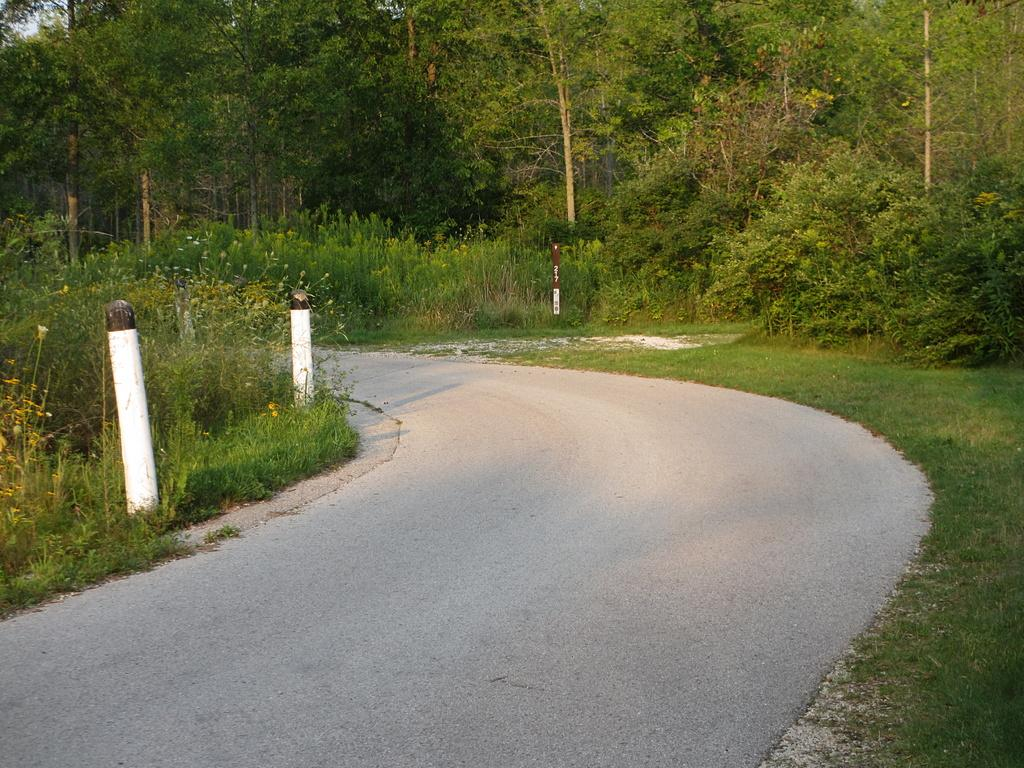What is the main feature of the image? There is a road in the image. What can be seen alongside the road? Barrier poles are present in the image. What type of vegetation is visible in the image? Shrubs, plants, and trees are visible in the image. What part of the natural environment is visible in the image? The sky is visible in the image. What type of hammer is the girl using to work on the road in the image? There is no girl or hammer present in the image; it only features a road, barrier poles, and vegetation. 